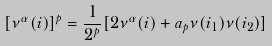Convert formula to latex. <formula><loc_0><loc_0><loc_500><loc_500>[ \nu ^ { \alpha } ( i ) ] ^ { p } = { \frac { 1 } { { 2 ^ { p } } } } [ 2 \nu ^ { \alpha } ( i ) + a _ { p } \nu ( i _ { 1 } ) \nu ( i _ { 2 } ) ]</formula> 